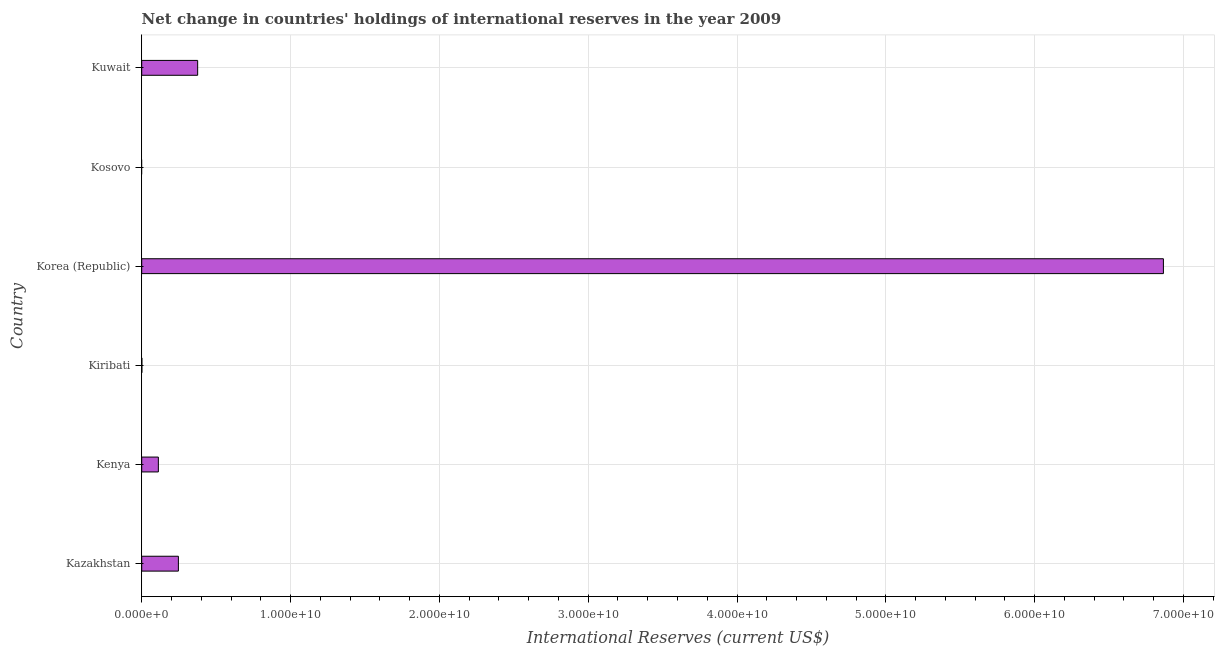Does the graph contain grids?
Provide a short and direct response. Yes. What is the title of the graph?
Offer a very short reply. Net change in countries' holdings of international reserves in the year 2009. What is the label or title of the X-axis?
Make the answer very short. International Reserves (current US$). What is the reserves and related items in Kiribati?
Your answer should be very brief. 9.89e+06. Across all countries, what is the maximum reserves and related items?
Your answer should be very brief. 6.87e+1. Across all countries, what is the minimum reserves and related items?
Offer a very short reply. 0. What is the sum of the reserves and related items?
Offer a terse response. 7.60e+1. What is the difference between the reserves and related items in Kenya and Korea (Republic)?
Provide a short and direct response. -6.75e+1. What is the average reserves and related items per country?
Offer a very short reply. 1.27e+1. What is the median reserves and related items?
Your answer should be compact. 1.79e+09. What is the ratio of the reserves and related items in Kenya to that in Korea (Republic)?
Offer a very short reply. 0.02. Is the reserves and related items in Kenya less than that in Kuwait?
Make the answer very short. Yes. Is the difference between the reserves and related items in Kazakhstan and Kenya greater than the difference between any two countries?
Offer a terse response. No. What is the difference between the highest and the second highest reserves and related items?
Your answer should be very brief. 6.49e+1. Is the sum of the reserves and related items in Kenya and Kiribati greater than the maximum reserves and related items across all countries?
Your answer should be compact. No. What is the difference between the highest and the lowest reserves and related items?
Your answer should be very brief. 6.87e+1. What is the difference between two consecutive major ticks on the X-axis?
Your response must be concise. 1.00e+1. What is the International Reserves (current US$) in Kazakhstan?
Offer a terse response. 2.46e+09. What is the International Reserves (current US$) in Kenya?
Make the answer very short. 1.12e+09. What is the International Reserves (current US$) of Kiribati?
Your answer should be compact. 9.89e+06. What is the International Reserves (current US$) in Korea (Republic)?
Provide a succinct answer. 6.87e+1. What is the International Reserves (current US$) in Kuwait?
Ensure brevity in your answer.  3.76e+09. What is the difference between the International Reserves (current US$) in Kazakhstan and Kenya?
Provide a succinct answer. 1.35e+09. What is the difference between the International Reserves (current US$) in Kazakhstan and Kiribati?
Provide a short and direct response. 2.45e+09. What is the difference between the International Reserves (current US$) in Kazakhstan and Korea (Republic)?
Offer a very short reply. -6.62e+1. What is the difference between the International Reserves (current US$) in Kazakhstan and Kuwait?
Make the answer very short. -1.29e+09. What is the difference between the International Reserves (current US$) in Kenya and Kiribati?
Offer a terse response. 1.11e+09. What is the difference between the International Reserves (current US$) in Kenya and Korea (Republic)?
Make the answer very short. -6.75e+1. What is the difference between the International Reserves (current US$) in Kenya and Kuwait?
Give a very brief answer. -2.64e+09. What is the difference between the International Reserves (current US$) in Kiribati and Korea (Republic)?
Offer a terse response. -6.86e+1. What is the difference between the International Reserves (current US$) in Kiribati and Kuwait?
Ensure brevity in your answer.  -3.75e+09. What is the difference between the International Reserves (current US$) in Korea (Republic) and Kuwait?
Your answer should be very brief. 6.49e+1. What is the ratio of the International Reserves (current US$) in Kazakhstan to that in Kenya?
Make the answer very short. 2.2. What is the ratio of the International Reserves (current US$) in Kazakhstan to that in Kiribati?
Provide a short and direct response. 249.16. What is the ratio of the International Reserves (current US$) in Kazakhstan to that in Korea (Republic)?
Your response must be concise. 0.04. What is the ratio of the International Reserves (current US$) in Kazakhstan to that in Kuwait?
Your response must be concise. 0.66. What is the ratio of the International Reserves (current US$) in Kenya to that in Kiribati?
Your answer should be compact. 113.06. What is the ratio of the International Reserves (current US$) in Kenya to that in Korea (Republic)?
Provide a short and direct response. 0.02. What is the ratio of the International Reserves (current US$) in Kenya to that in Kuwait?
Provide a succinct answer. 0.3. What is the ratio of the International Reserves (current US$) in Kiribati to that in Korea (Republic)?
Give a very brief answer. 0. What is the ratio of the International Reserves (current US$) in Kiribati to that in Kuwait?
Your response must be concise. 0. What is the ratio of the International Reserves (current US$) in Korea (Republic) to that in Kuwait?
Provide a short and direct response. 18.27. 